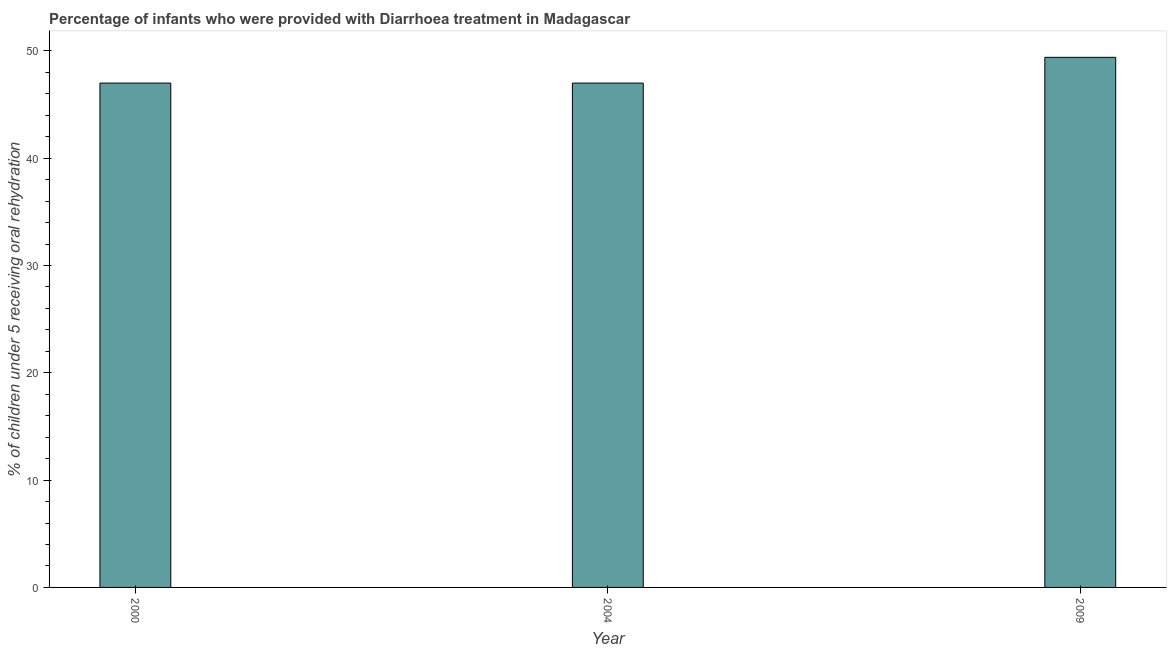Does the graph contain any zero values?
Keep it short and to the point. No. Does the graph contain grids?
Your answer should be compact. No. What is the title of the graph?
Your answer should be very brief. Percentage of infants who were provided with Diarrhoea treatment in Madagascar. What is the label or title of the X-axis?
Your answer should be compact. Year. What is the label or title of the Y-axis?
Your response must be concise. % of children under 5 receiving oral rehydration. Across all years, what is the maximum percentage of children who were provided with treatment diarrhoea?
Your answer should be compact. 49.4. In which year was the percentage of children who were provided with treatment diarrhoea minimum?
Your response must be concise. 2000. What is the sum of the percentage of children who were provided with treatment diarrhoea?
Offer a very short reply. 143.4. What is the average percentage of children who were provided with treatment diarrhoea per year?
Ensure brevity in your answer.  47.8. What is the median percentage of children who were provided with treatment diarrhoea?
Offer a very short reply. 47. In how many years, is the percentage of children who were provided with treatment diarrhoea greater than 24 %?
Make the answer very short. 3. What is the ratio of the percentage of children who were provided with treatment diarrhoea in 2004 to that in 2009?
Offer a terse response. 0.95. What is the difference between the highest and the second highest percentage of children who were provided with treatment diarrhoea?
Provide a succinct answer. 2.4. Is the sum of the percentage of children who were provided with treatment diarrhoea in 2000 and 2009 greater than the maximum percentage of children who were provided with treatment diarrhoea across all years?
Your answer should be compact. Yes. What is the difference between the highest and the lowest percentage of children who were provided with treatment diarrhoea?
Provide a short and direct response. 2.4. How many bars are there?
Ensure brevity in your answer.  3. Are all the bars in the graph horizontal?
Offer a very short reply. No. How many years are there in the graph?
Make the answer very short. 3. What is the difference between two consecutive major ticks on the Y-axis?
Keep it short and to the point. 10. What is the % of children under 5 receiving oral rehydration of 2004?
Your answer should be very brief. 47. What is the % of children under 5 receiving oral rehydration of 2009?
Keep it short and to the point. 49.4. What is the difference between the % of children under 5 receiving oral rehydration in 2000 and 2004?
Provide a succinct answer. 0. What is the difference between the % of children under 5 receiving oral rehydration in 2000 and 2009?
Provide a short and direct response. -2.4. What is the ratio of the % of children under 5 receiving oral rehydration in 2000 to that in 2009?
Your answer should be very brief. 0.95. What is the ratio of the % of children under 5 receiving oral rehydration in 2004 to that in 2009?
Keep it short and to the point. 0.95. 